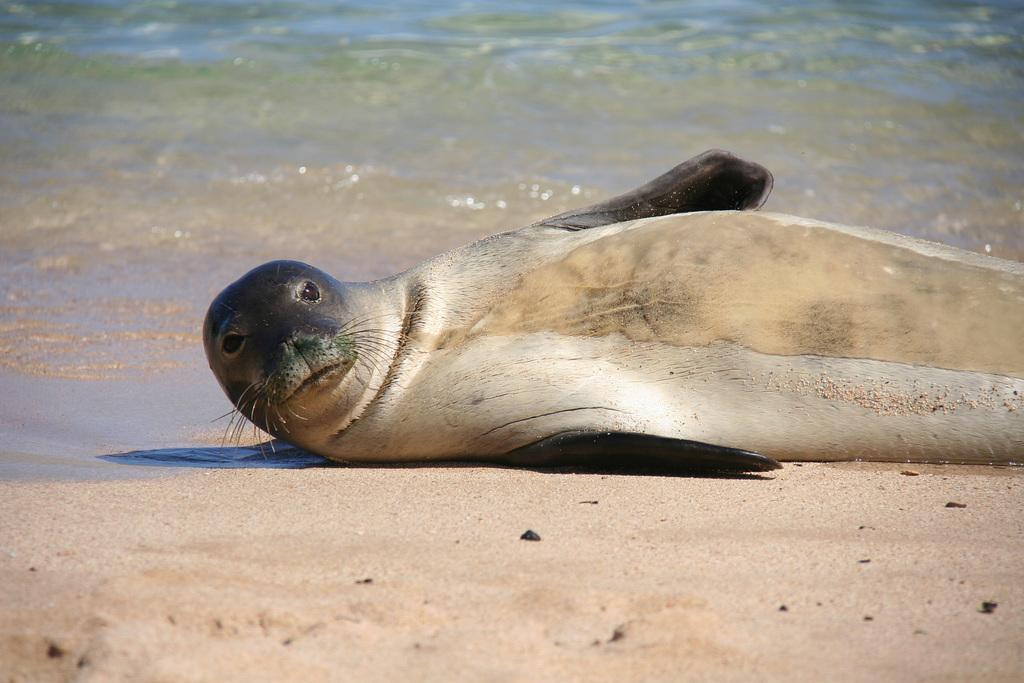What type of animal is in the image? There is a seal in the image. Where is the seal located? The seal is on a sea beach. What can be seen in the background of the image? There is water visible in the background of the image. What verse is the seal reciting in the image? There is no indication in the image that the seal is reciting a verse. Are there any police officers present in the image? There is no reference to police officers in the image. 